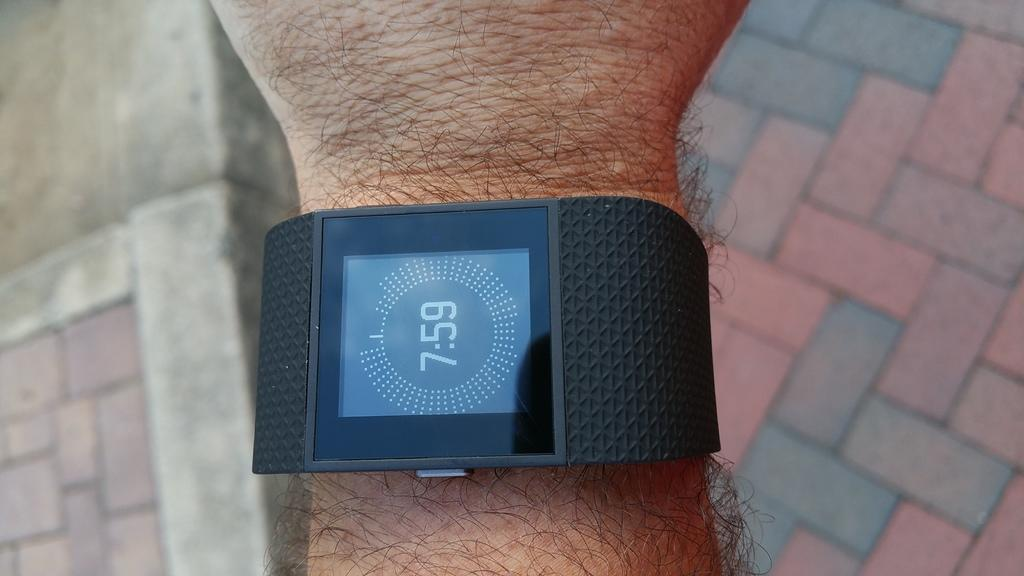<image>
Relay a brief, clear account of the picture shown. The time of "7:59" is shown on a black watch. 